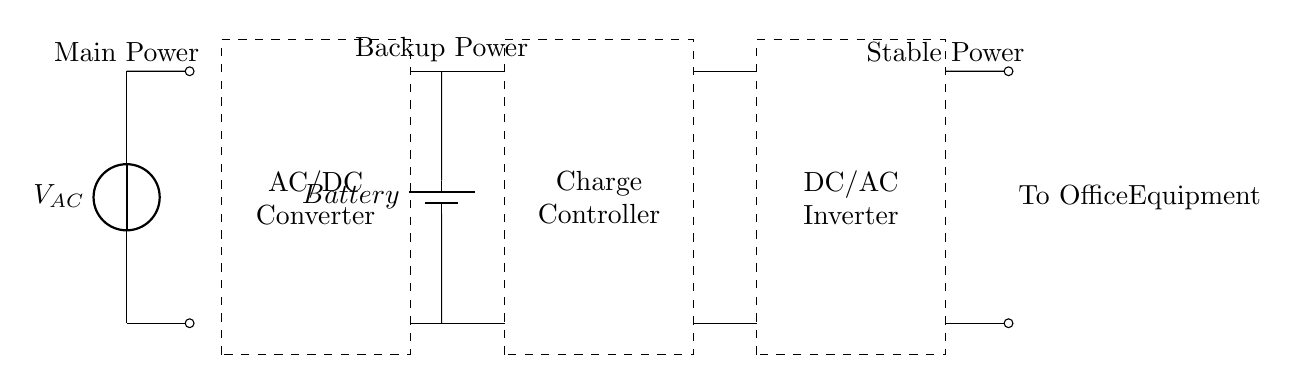What is the main power source for this circuit? The main power source is represented by the symbol labeled V_{AC}, which indicates an alternating current voltage source.
Answer: AC voltage source What component converts AC to DC? The AC/DC converter is the component that changes alternating current (AC) voltage to direct current (DC) voltage, allowing for efficient battery charging.
Answer: AC/DC Converter What is the purpose of the charge controller? The charge controller ensures that the battery is charged correctly and prevents overcharging, maintaining optimal battery health.
Answer: Maintain battery health What type of inverter is used in this circuit? The circuit contains a DC/AC inverter, which converts the stored direct current (DC) from the battery back into alternating current (AC) for use by office equipment.
Answer: DC/AC How does power flow when main power is unavailable? When the main power is unavailable, the circuit uses the battery to supply stable power through the inverter to the office equipment, maintaining operation during power outages.
Answer: Through the battery What components can be affected if the charge controller fails? If the charge controller fails, the battery can become overcharged or deeply discharged, which could potentially damage the battery and affect the performance of the DC/AC inverter connected to the office equipment.
Answer: Battery and inverter 